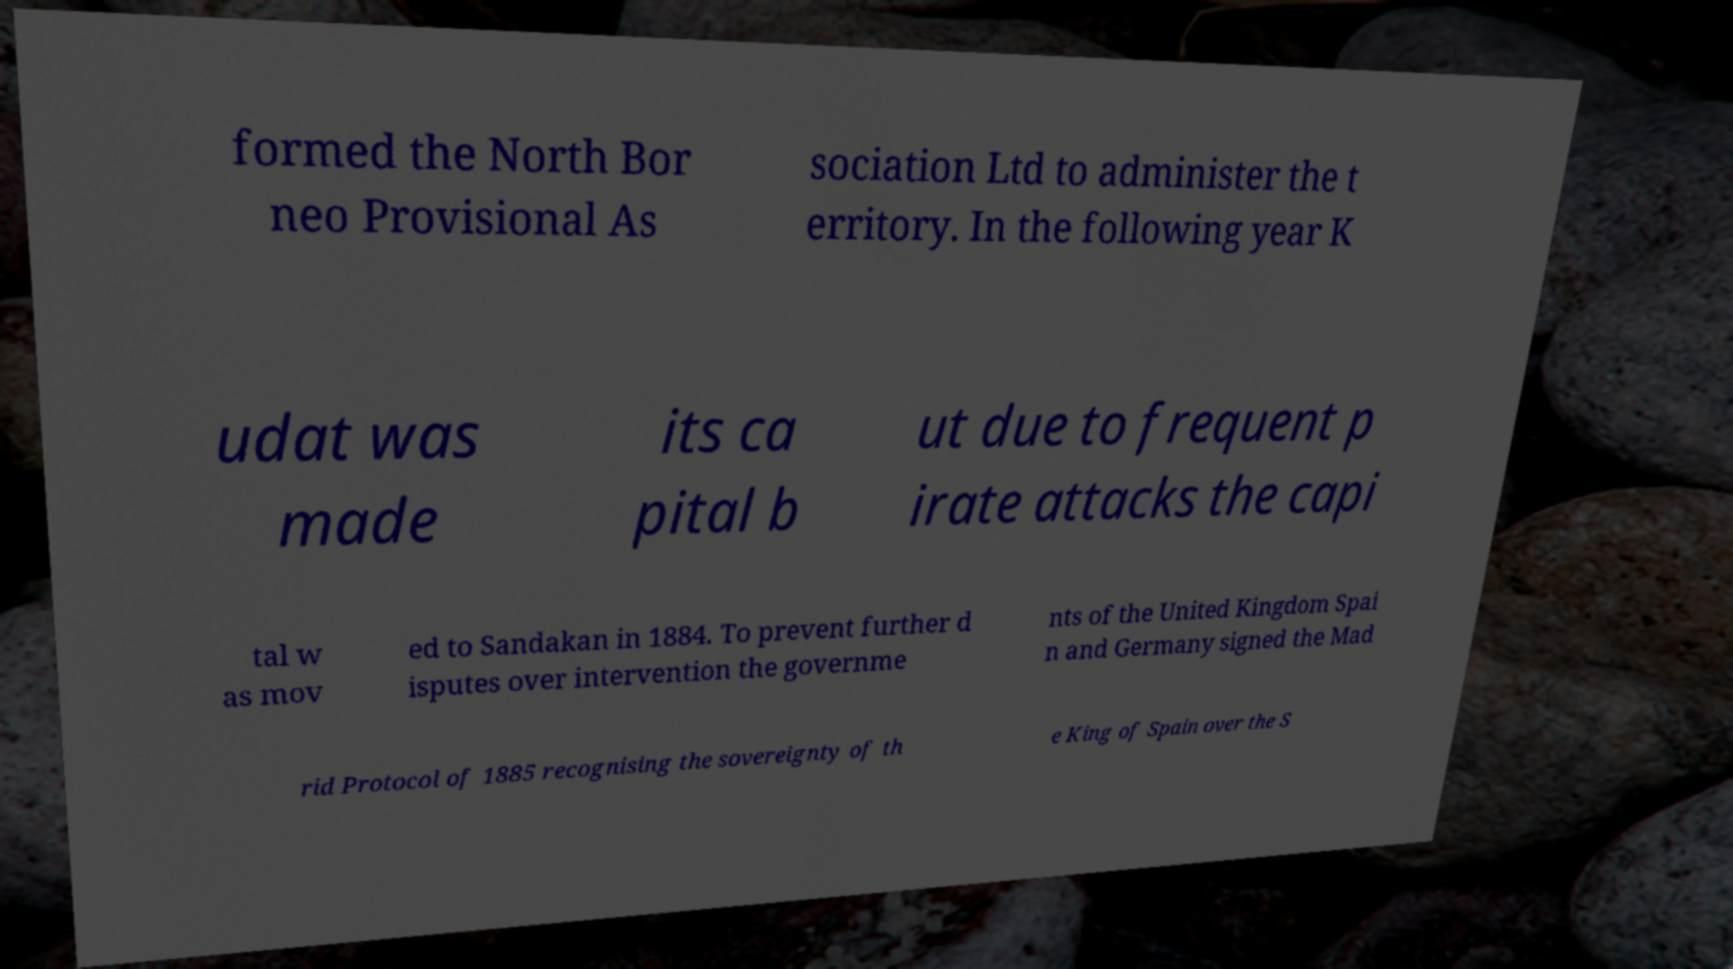Can you read and provide the text displayed in the image?This photo seems to have some interesting text. Can you extract and type it out for me? formed the North Bor neo Provisional As sociation Ltd to administer the t erritory. In the following year K udat was made its ca pital b ut due to frequent p irate attacks the capi tal w as mov ed to Sandakan in 1884. To prevent further d isputes over intervention the governme nts of the United Kingdom Spai n and Germany signed the Mad rid Protocol of 1885 recognising the sovereignty of th e King of Spain over the S 